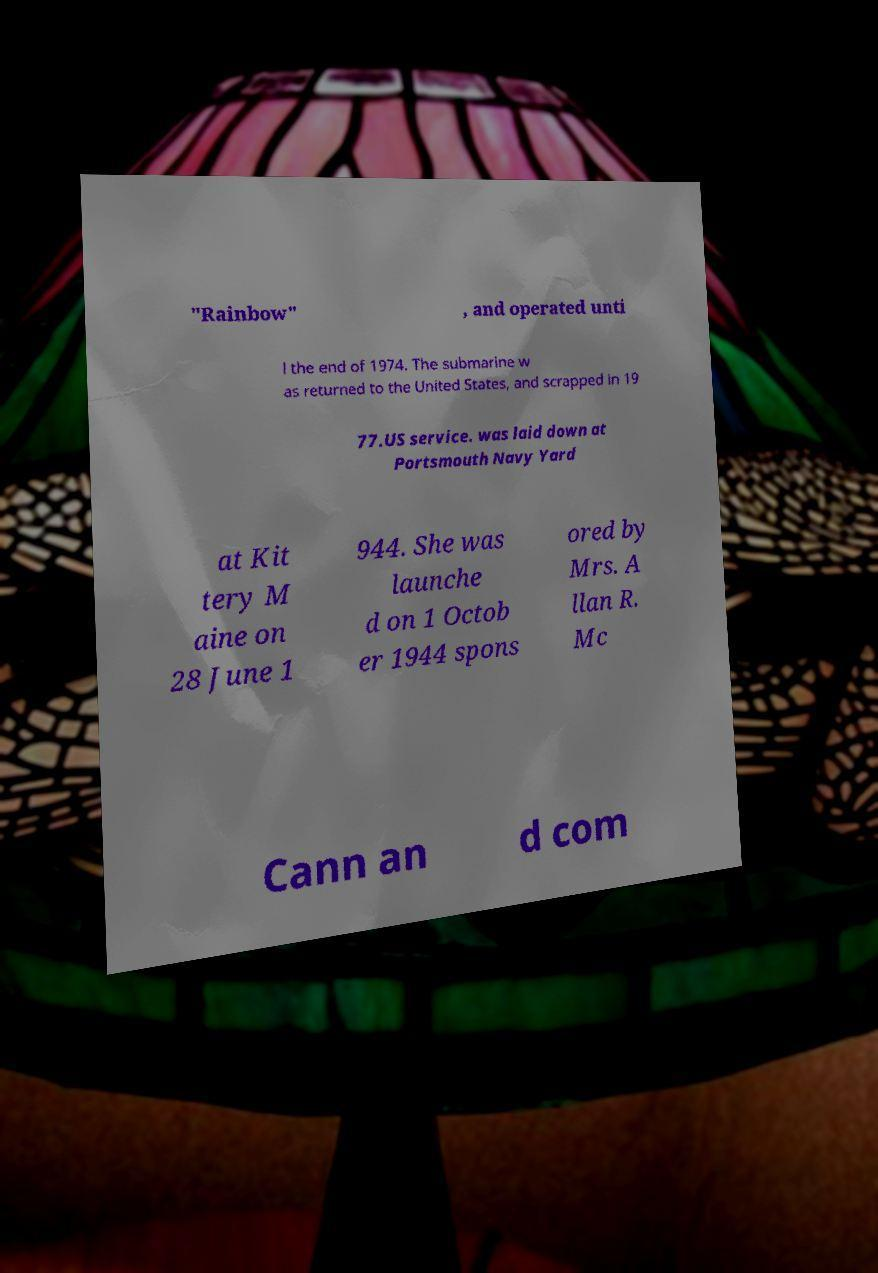Can you accurately transcribe the text from the provided image for me? "Rainbow" , and operated unti l the end of 1974. The submarine w as returned to the United States, and scrapped in 19 77.US service. was laid down at Portsmouth Navy Yard at Kit tery M aine on 28 June 1 944. She was launche d on 1 Octob er 1944 spons ored by Mrs. A llan R. Mc Cann an d com 